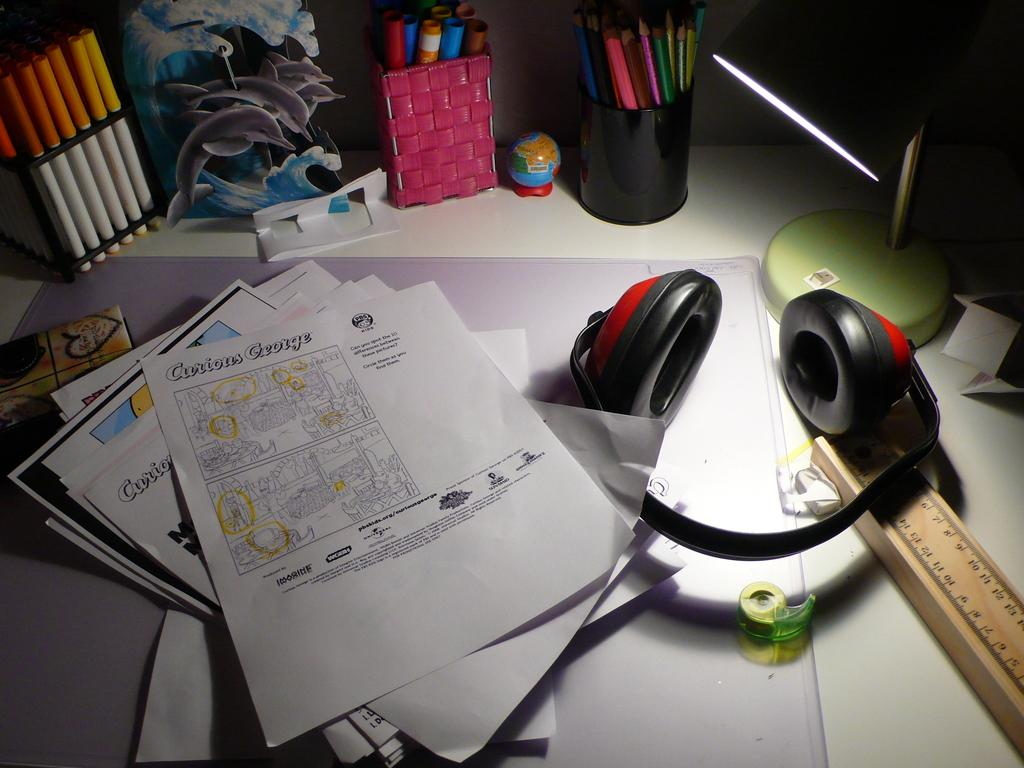What is the main piece of furniture in the image? There is a table in the image. What items can be seen on the table? Papers, a scale, a pencil box, a sketch box, a pens box, and a headphone are visible on the table. What might be used for drawing or sketching in the image? The sketch box on the table might be used for drawing or sketching. What might be used for writing in the image? The pencil box and pens box on the table might be used for writing. What type of current is flowing through the headphone in the image? There is no indication of any current flowing through the headphone in the image. 